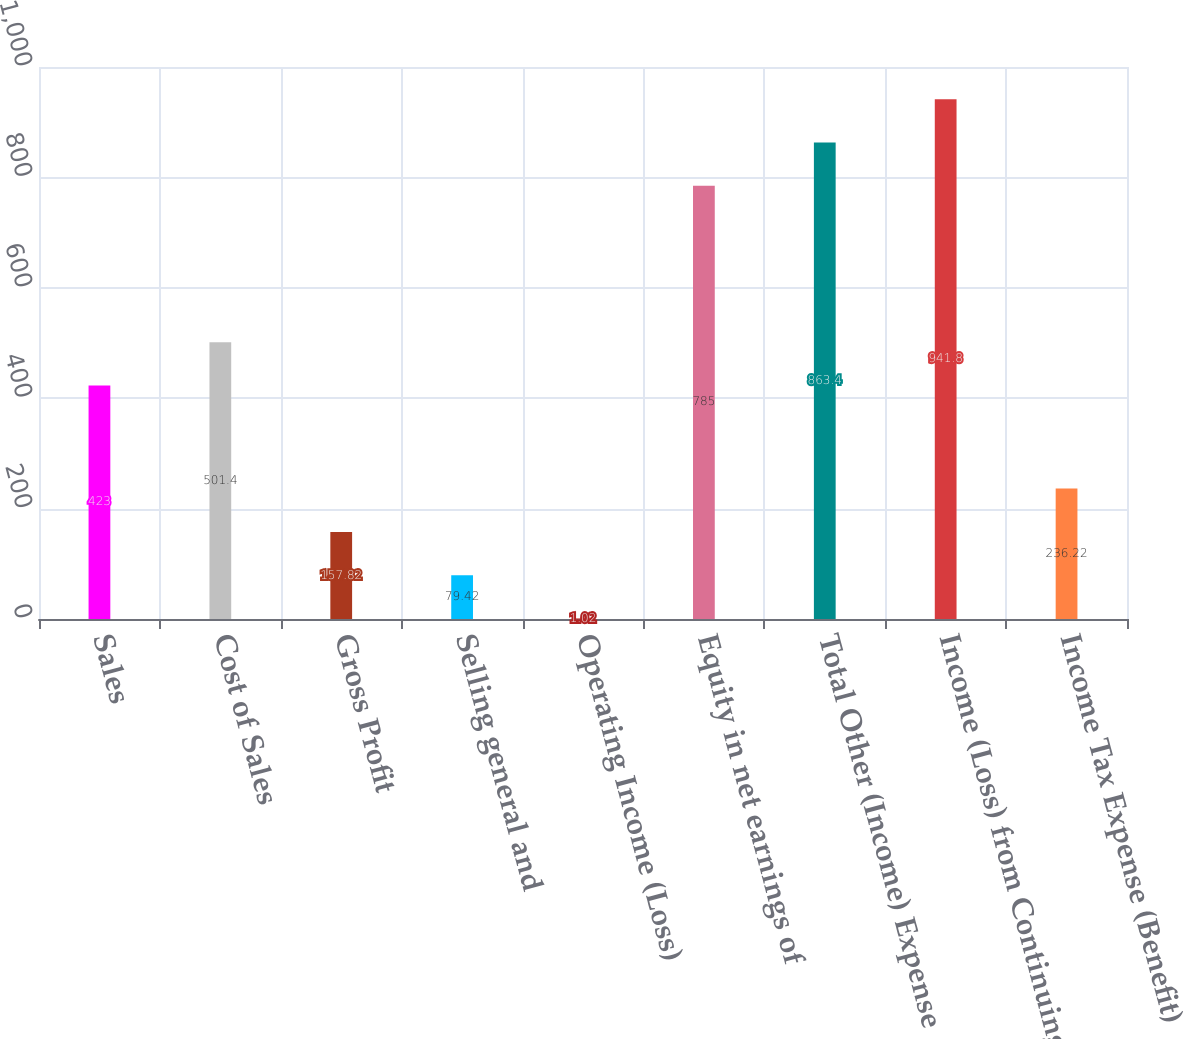Convert chart to OTSL. <chart><loc_0><loc_0><loc_500><loc_500><bar_chart><fcel>Sales<fcel>Cost of Sales<fcel>Gross Profit<fcel>Selling general and<fcel>Operating Income (Loss)<fcel>Equity in net earnings of<fcel>Total Other (Income) Expense<fcel>Income (Loss) from Continuing<fcel>Income Tax Expense (Benefit)<nl><fcel>423<fcel>501.4<fcel>157.82<fcel>79.42<fcel>1.02<fcel>785<fcel>863.4<fcel>941.8<fcel>236.22<nl></chart> 